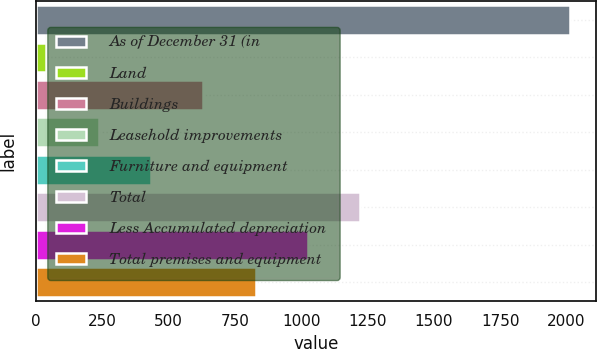<chart> <loc_0><loc_0><loc_500><loc_500><bar_chart><fcel>As of December 31 (in<fcel>Land<fcel>Buildings<fcel>Leasehold improvements<fcel>Furniture and equipment<fcel>Total<fcel>Less Accumulated depreciation<fcel>Total premises and equipment<nl><fcel>2012<fcel>39.7<fcel>631.39<fcel>236.93<fcel>434.16<fcel>1223.08<fcel>1025.85<fcel>828.62<nl></chart> 